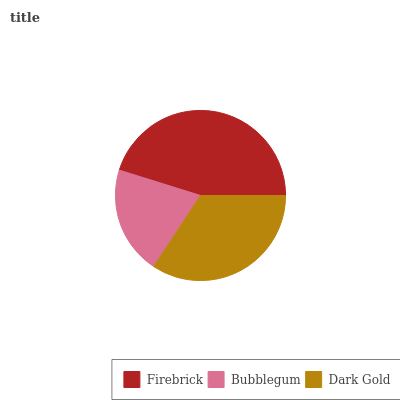Is Bubblegum the minimum?
Answer yes or no. Yes. Is Firebrick the maximum?
Answer yes or no. Yes. Is Dark Gold the minimum?
Answer yes or no. No. Is Dark Gold the maximum?
Answer yes or no. No. Is Dark Gold greater than Bubblegum?
Answer yes or no. Yes. Is Bubblegum less than Dark Gold?
Answer yes or no. Yes. Is Bubblegum greater than Dark Gold?
Answer yes or no. No. Is Dark Gold less than Bubblegum?
Answer yes or no. No. Is Dark Gold the high median?
Answer yes or no. Yes. Is Dark Gold the low median?
Answer yes or no. Yes. Is Firebrick the high median?
Answer yes or no. No. Is Bubblegum the low median?
Answer yes or no. No. 